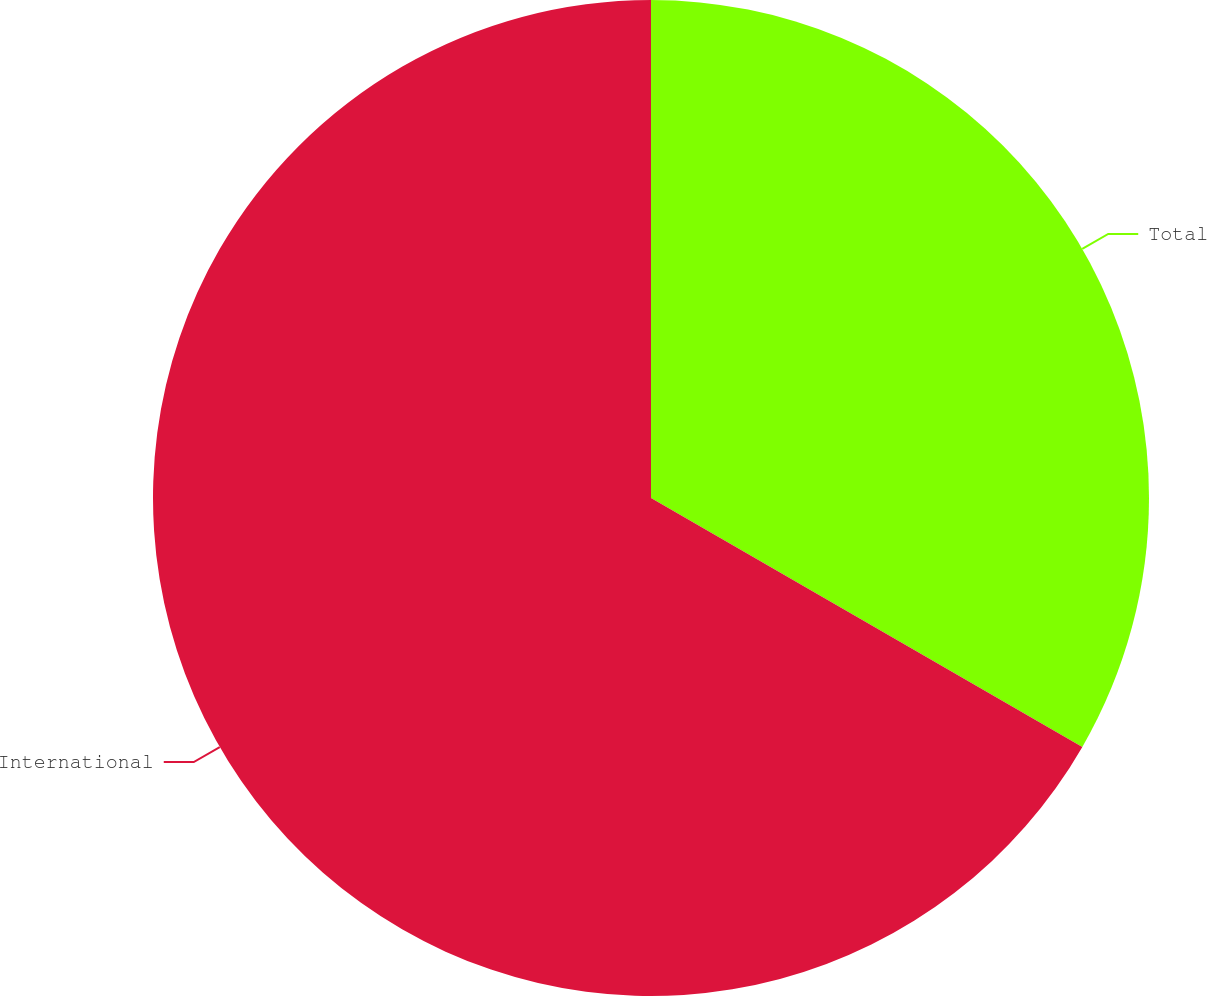Convert chart. <chart><loc_0><loc_0><loc_500><loc_500><pie_chart><fcel>Total<fcel>International<nl><fcel>33.33%<fcel>66.67%<nl></chart> 